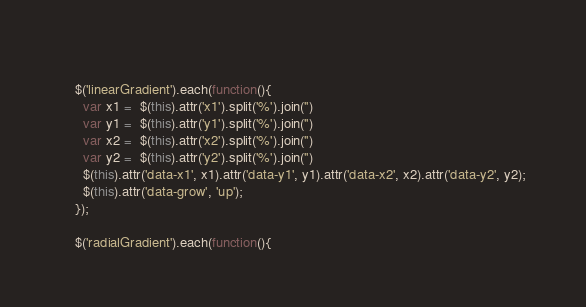<code> <loc_0><loc_0><loc_500><loc_500><_JavaScript_>    
    $('linearGradient').each(function(){
      var x1 =  $(this).attr('x1').split('%').join('')
      var y1 =  $(this).attr('y1').split('%').join('')
      var x2 =  $(this).attr('x2').split('%').join('')
      var y2 =  $(this).attr('y2').split('%').join('')
      $(this).attr('data-x1', x1).attr('data-y1', y1).attr('data-x2', x2).attr('data-y2', y2);
      $(this).attr('data-grow', 'up');
    });
  
    $('radialGradient').each(function(){</code> 